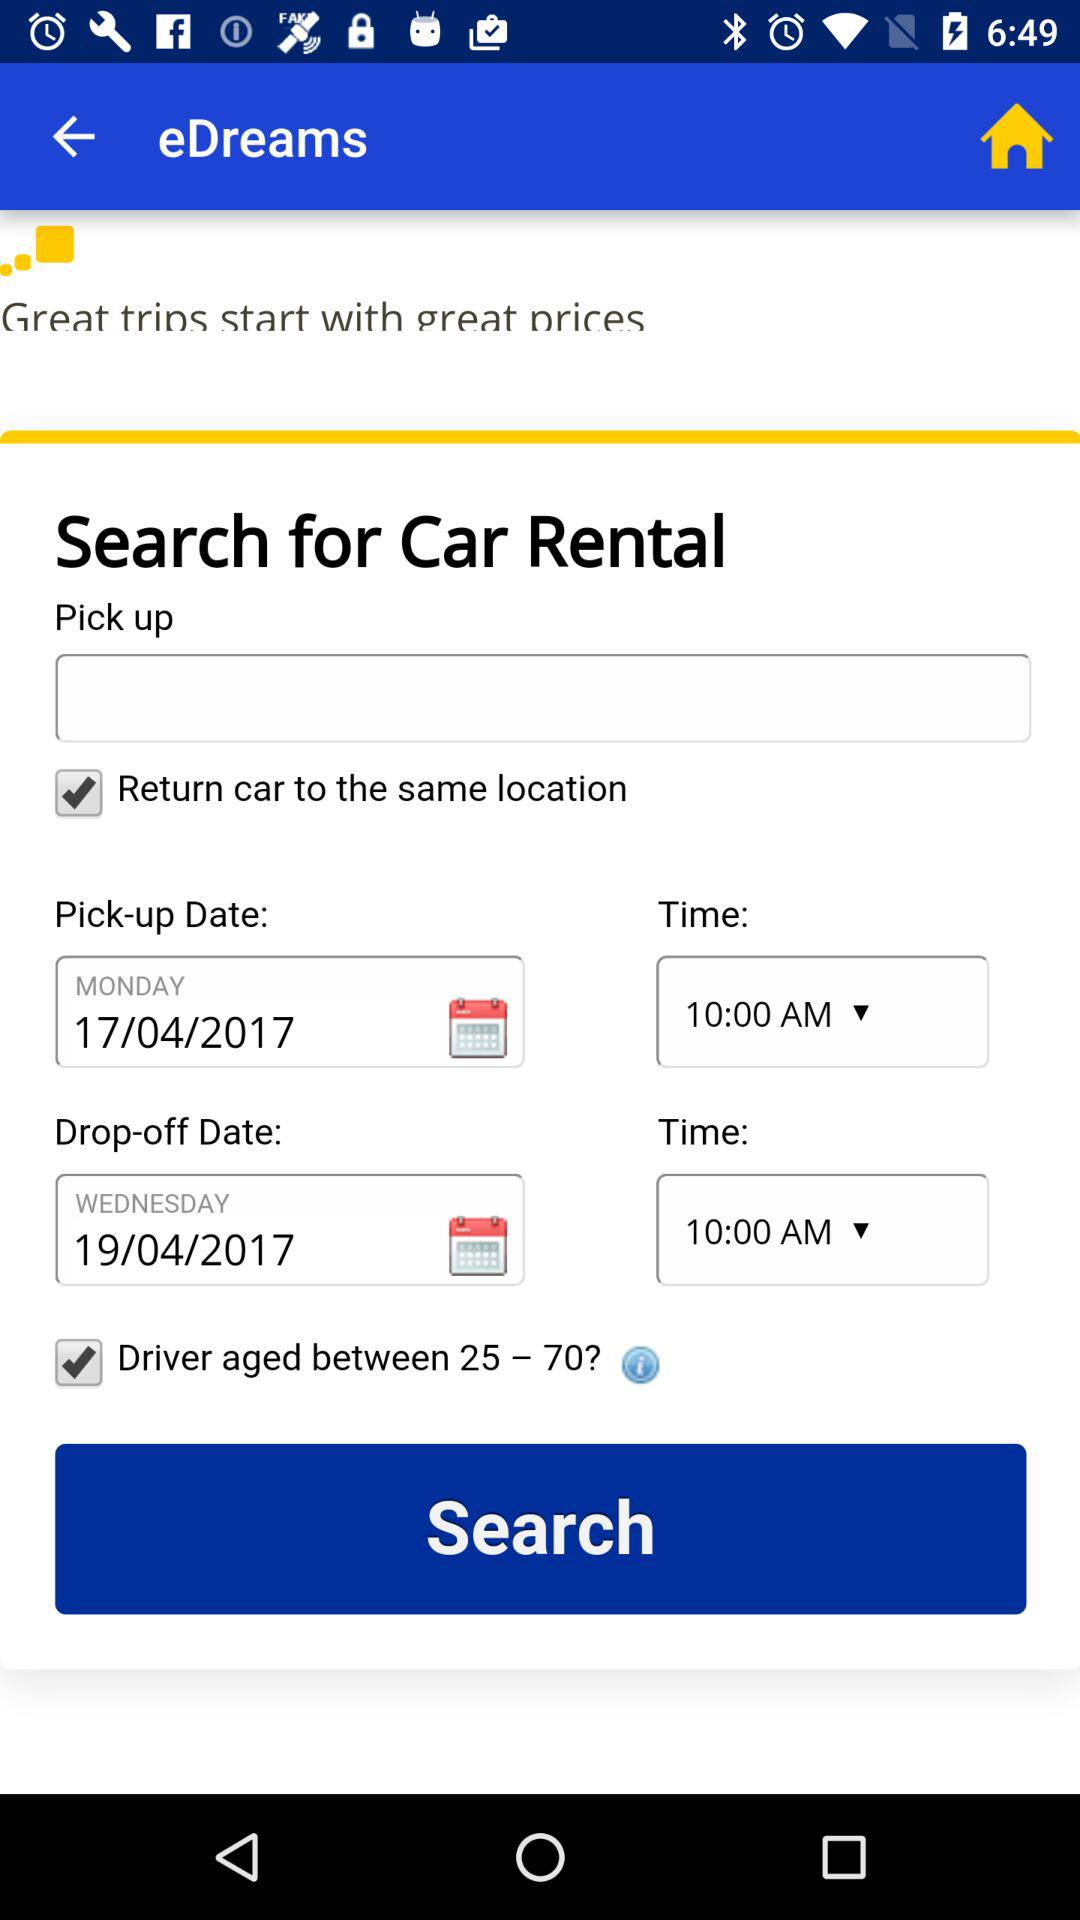What is the time? The time is 10:00 a.m. 